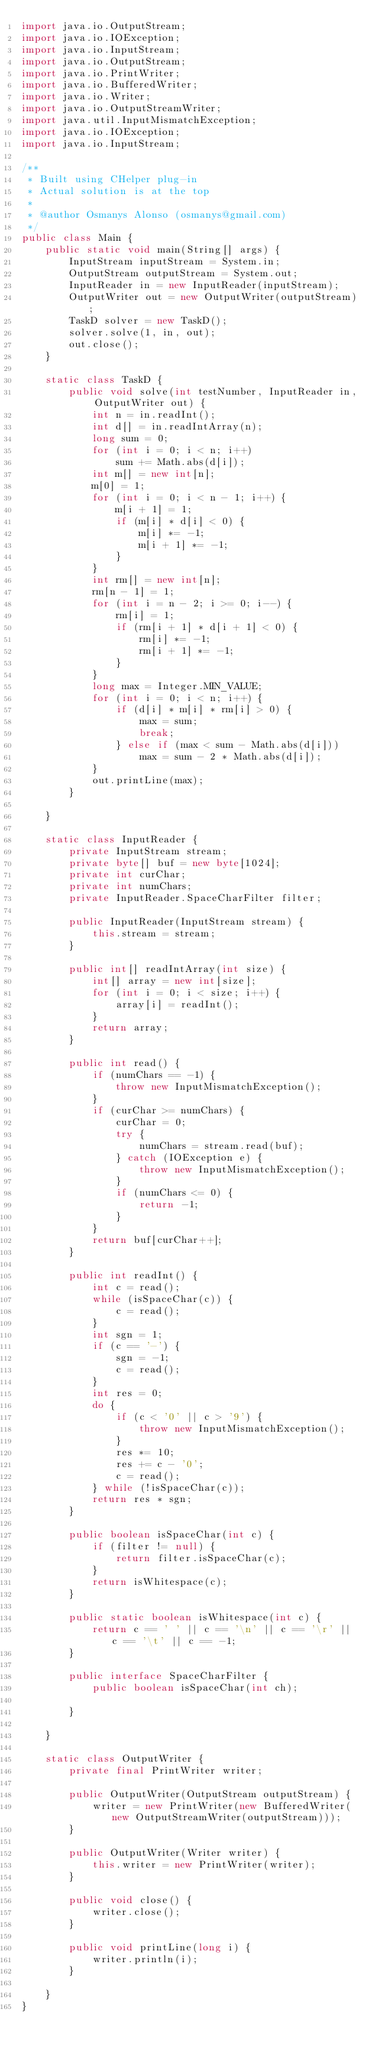Convert code to text. <code><loc_0><loc_0><loc_500><loc_500><_Java_>import java.io.OutputStream;
import java.io.IOException;
import java.io.InputStream;
import java.io.OutputStream;
import java.io.PrintWriter;
import java.io.BufferedWriter;
import java.io.Writer;
import java.io.OutputStreamWriter;
import java.util.InputMismatchException;
import java.io.IOException;
import java.io.InputStream;

/**
 * Built using CHelper plug-in
 * Actual solution is at the top
 *
 * @author Osmanys Alonso (osmanys@gmail.com)
 */
public class Main {
    public static void main(String[] args) {
        InputStream inputStream = System.in;
        OutputStream outputStream = System.out;
        InputReader in = new InputReader(inputStream);
        OutputWriter out = new OutputWriter(outputStream);
        TaskD solver = new TaskD();
        solver.solve(1, in, out);
        out.close();
    }

    static class TaskD {
        public void solve(int testNumber, InputReader in, OutputWriter out) {
            int n = in.readInt();
            int d[] = in.readIntArray(n);
            long sum = 0;
            for (int i = 0; i < n; i++)
                sum += Math.abs(d[i]);
            int m[] = new int[n];
            m[0] = 1;
            for (int i = 0; i < n - 1; i++) {
                m[i + 1] = 1;
                if (m[i] * d[i] < 0) {
                    m[i] *= -1;
                    m[i + 1] *= -1;
                }
            }
            int rm[] = new int[n];
            rm[n - 1] = 1;
            for (int i = n - 2; i >= 0; i--) {
                rm[i] = 1;
                if (rm[i + 1] * d[i + 1] < 0) {
                    rm[i] *= -1;
                    rm[i + 1] *= -1;
                }
            }
            long max = Integer.MIN_VALUE;
            for (int i = 0; i < n; i++) {
                if (d[i] * m[i] * rm[i] > 0) {
                    max = sum;
                    break;
                } else if (max < sum - Math.abs(d[i]))
                    max = sum - 2 * Math.abs(d[i]);
            }
            out.printLine(max);
        }

    }

    static class InputReader {
        private InputStream stream;
        private byte[] buf = new byte[1024];
        private int curChar;
        private int numChars;
        private InputReader.SpaceCharFilter filter;

        public InputReader(InputStream stream) {
            this.stream = stream;
        }

        public int[] readIntArray(int size) {
            int[] array = new int[size];
            for (int i = 0; i < size; i++) {
                array[i] = readInt();
            }
            return array;
        }

        public int read() {
            if (numChars == -1) {
                throw new InputMismatchException();
            }
            if (curChar >= numChars) {
                curChar = 0;
                try {
                    numChars = stream.read(buf);
                } catch (IOException e) {
                    throw new InputMismatchException();
                }
                if (numChars <= 0) {
                    return -1;
                }
            }
            return buf[curChar++];
        }

        public int readInt() {
            int c = read();
            while (isSpaceChar(c)) {
                c = read();
            }
            int sgn = 1;
            if (c == '-') {
                sgn = -1;
                c = read();
            }
            int res = 0;
            do {
                if (c < '0' || c > '9') {
                    throw new InputMismatchException();
                }
                res *= 10;
                res += c - '0';
                c = read();
            } while (!isSpaceChar(c));
            return res * sgn;
        }

        public boolean isSpaceChar(int c) {
            if (filter != null) {
                return filter.isSpaceChar(c);
            }
            return isWhitespace(c);
        }

        public static boolean isWhitespace(int c) {
            return c == ' ' || c == '\n' || c == '\r' || c == '\t' || c == -1;
        }

        public interface SpaceCharFilter {
            public boolean isSpaceChar(int ch);

        }

    }

    static class OutputWriter {
        private final PrintWriter writer;

        public OutputWriter(OutputStream outputStream) {
            writer = new PrintWriter(new BufferedWriter(new OutputStreamWriter(outputStream)));
        }

        public OutputWriter(Writer writer) {
            this.writer = new PrintWriter(writer);
        }

        public void close() {
            writer.close();
        }

        public void printLine(long i) {
            writer.println(i);
        }

    }
}

</code> 